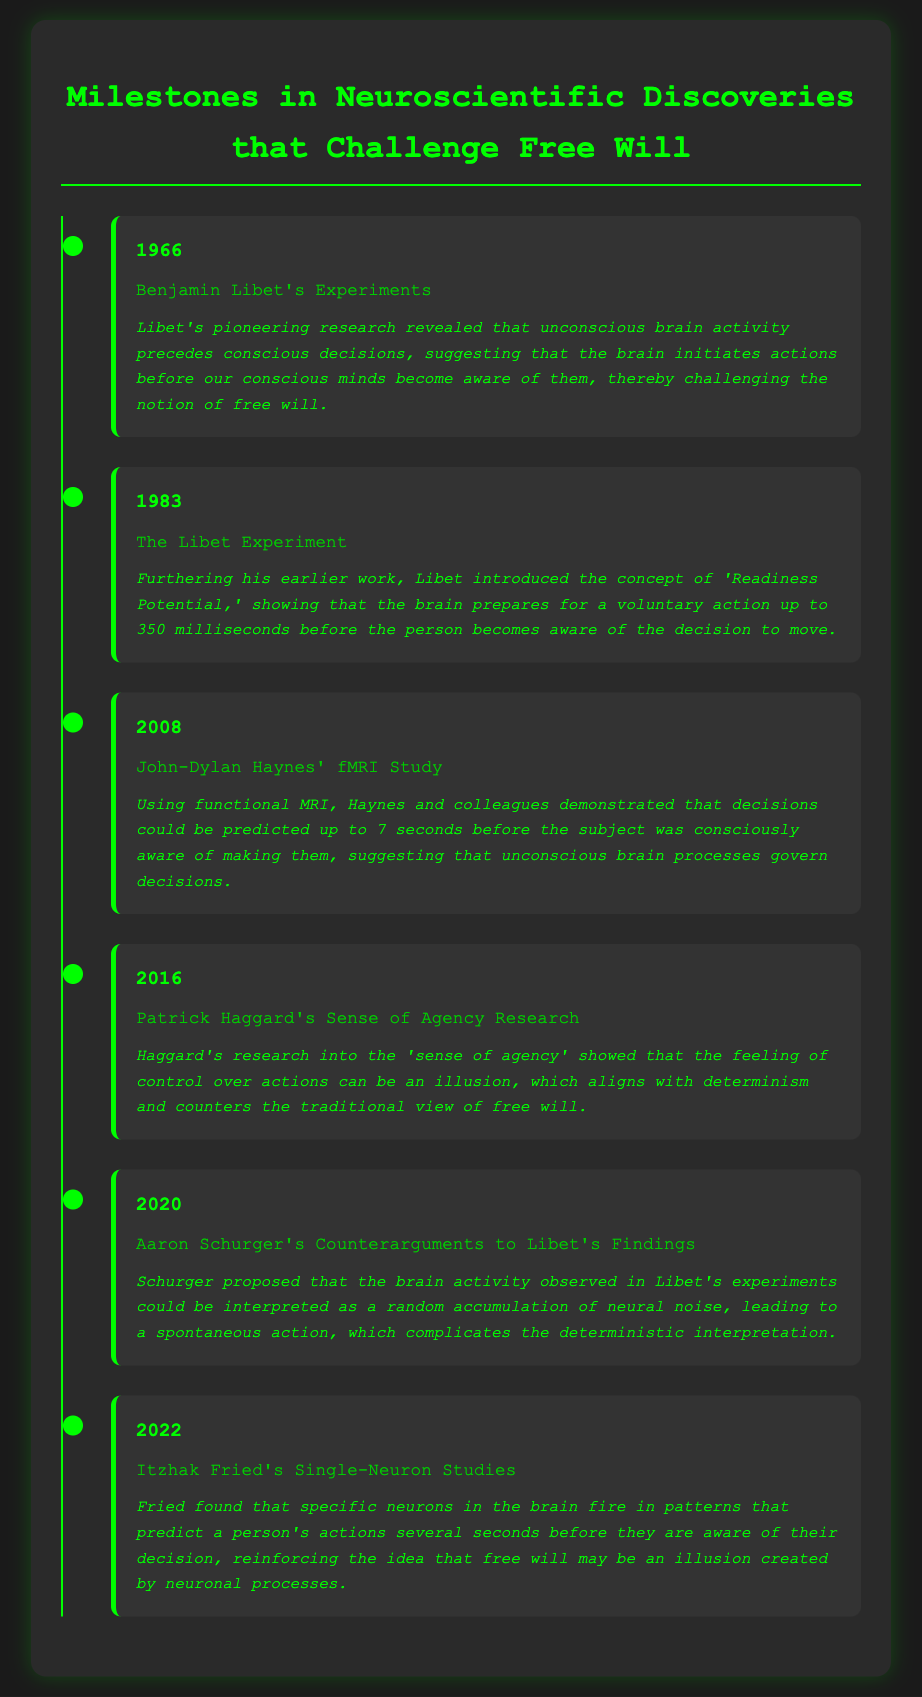what year was Benjamin Libet's experiment conducted? The year of Benjamin Libet's experiment is stated as 1966 in the document.
Answer: 1966 what concept did Libet introduce in 1983? Libet introduced the concept of 'Readiness Potential' in 1983 as mentioned in the document.
Answer: 'Readiness Potential' how many seconds before conscious awareness could decisions be predicted in Haynes' study? The document states that decisions could be predicted up to 7 seconds before conscious awareness in Haynes' study.
Answer: 7 seconds who conducted research into the 'sense of agency' in 2016? The document identifies Patrick Haggard as the researcher who studied the 'sense of agency' in 2016.
Answer: Patrick Haggard what is the main counterargument presented by Aaron Schurger in 2020? Schurger's counterargument discusses the interpretation of brain activity as a random accumulation of neural noise, as stated in the document.
Answer: Random accumulation of neural noise what does Itzhak Fried's 2022 research reinforce? Fried's research reinforces the idea that free will may be an illusion, according to the document.
Answer: Free will may be an illusion how does the timeline structure of the document enhance understanding? The timeline format organizes the discoveries chronologically, making it easier to understand their progression and impact.
Answer: Chronologically what is the dominant color scheme used in the infographic? The dominant color scheme in the infographic is black with green accents as indicated in the visual description.
Answer: Black and green 